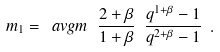Convert formula to latex. <formula><loc_0><loc_0><loc_500><loc_500>m _ { 1 } = \ a v g { m } \ \frac { 2 + \beta } { 1 + \beta } \ \frac { q ^ { 1 + \beta } - 1 } { q ^ { 2 + \beta } - 1 } \ .</formula> 